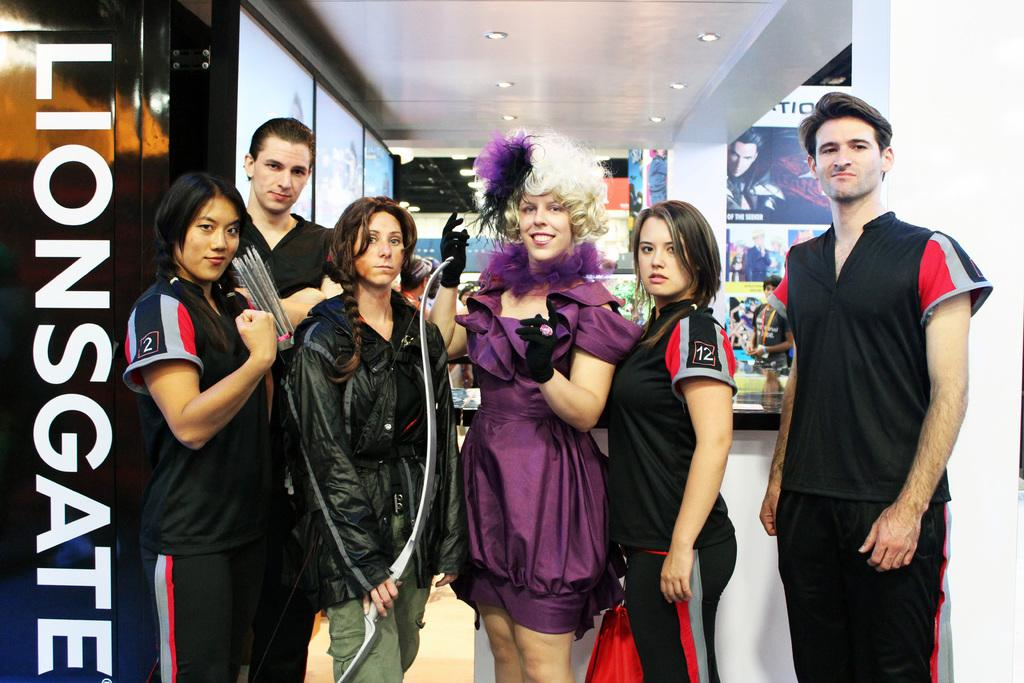<image>
Present a compact description of the photo's key features. A group of hunger games cosplayers pose next to a Lionsgate sign 